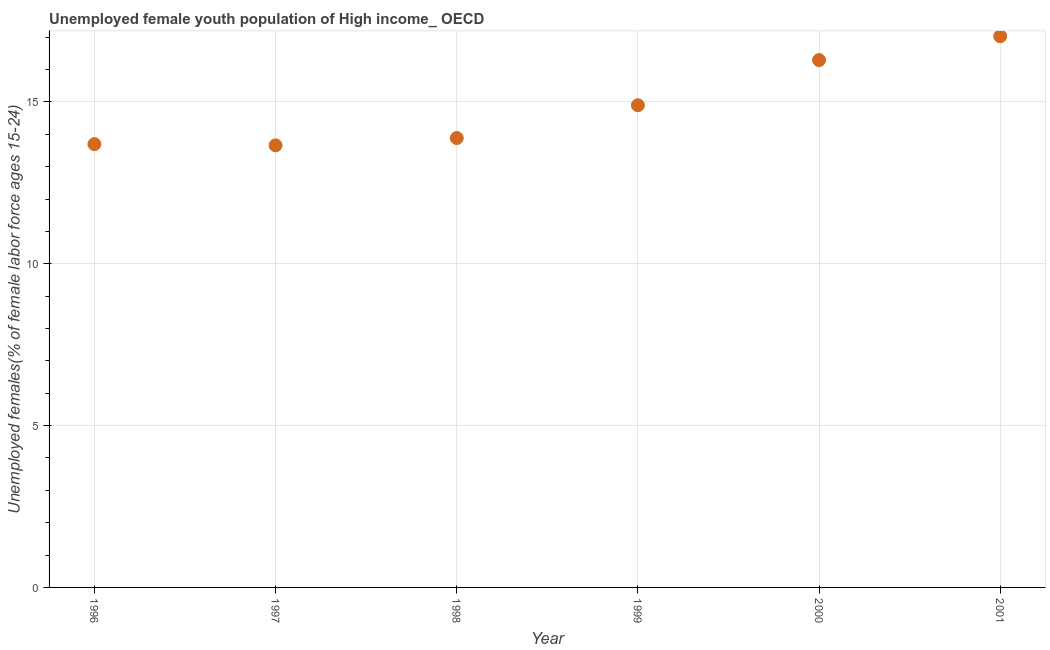What is the unemployed female youth in 1996?
Your answer should be very brief. 13.7. Across all years, what is the maximum unemployed female youth?
Your answer should be compact. 17.03. Across all years, what is the minimum unemployed female youth?
Offer a very short reply. 13.66. In which year was the unemployed female youth maximum?
Provide a succinct answer. 2001. In which year was the unemployed female youth minimum?
Make the answer very short. 1997. What is the sum of the unemployed female youth?
Your answer should be compact. 89.46. What is the difference between the unemployed female youth in 1998 and 2000?
Provide a succinct answer. -2.41. What is the average unemployed female youth per year?
Offer a very short reply. 14.91. What is the median unemployed female youth?
Ensure brevity in your answer.  14.39. In how many years, is the unemployed female youth greater than 14 %?
Offer a terse response. 3. What is the ratio of the unemployed female youth in 1998 to that in 2000?
Your answer should be very brief. 0.85. What is the difference between the highest and the second highest unemployed female youth?
Your answer should be very brief. 0.74. Is the sum of the unemployed female youth in 1996 and 1999 greater than the maximum unemployed female youth across all years?
Provide a short and direct response. Yes. What is the difference between the highest and the lowest unemployed female youth?
Provide a short and direct response. 3.37. Does the unemployed female youth monotonically increase over the years?
Make the answer very short. No. How many dotlines are there?
Your answer should be compact. 1. What is the difference between two consecutive major ticks on the Y-axis?
Offer a terse response. 5. Does the graph contain grids?
Provide a succinct answer. Yes. What is the title of the graph?
Offer a very short reply. Unemployed female youth population of High income_ OECD. What is the label or title of the Y-axis?
Offer a very short reply. Unemployed females(% of female labor force ages 15-24). What is the Unemployed females(% of female labor force ages 15-24) in 1996?
Offer a very short reply. 13.7. What is the Unemployed females(% of female labor force ages 15-24) in 1997?
Your response must be concise. 13.66. What is the Unemployed females(% of female labor force ages 15-24) in 1998?
Give a very brief answer. 13.88. What is the Unemployed females(% of female labor force ages 15-24) in 1999?
Provide a succinct answer. 14.9. What is the Unemployed females(% of female labor force ages 15-24) in 2000?
Offer a terse response. 16.29. What is the Unemployed females(% of female labor force ages 15-24) in 2001?
Provide a succinct answer. 17.03. What is the difference between the Unemployed females(% of female labor force ages 15-24) in 1996 and 1997?
Your answer should be very brief. 0.04. What is the difference between the Unemployed females(% of female labor force ages 15-24) in 1996 and 1998?
Offer a very short reply. -0.19. What is the difference between the Unemployed females(% of female labor force ages 15-24) in 1996 and 1999?
Your answer should be very brief. -1.2. What is the difference between the Unemployed females(% of female labor force ages 15-24) in 1996 and 2000?
Offer a terse response. -2.6. What is the difference between the Unemployed females(% of female labor force ages 15-24) in 1996 and 2001?
Your answer should be compact. -3.33. What is the difference between the Unemployed females(% of female labor force ages 15-24) in 1997 and 1998?
Your answer should be very brief. -0.22. What is the difference between the Unemployed females(% of female labor force ages 15-24) in 1997 and 1999?
Provide a succinct answer. -1.24. What is the difference between the Unemployed females(% of female labor force ages 15-24) in 1997 and 2000?
Keep it short and to the point. -2.63. What is the difference between the Unemployed females(% of female labor force ages 15-24) in 1997 and 2001?
Offer a terse response. -3.37. What is the difference between the Unemployed females(% of female labor force ages 15-24) in 1998 and 1999?
Give a very brief answer. -1.01. What is the difference between the Unemployed females(% of female labor force ages 15-24) in 1998 and 2000?
Offer a very short reply. -2.41. What is the difference between the Unemployed females(% of female labor force ages 15-24) in 1998 and 2001?
Your answer should be compact. -3.14. What is the difference between the Unemployed females(% of female labor force ages 15-24) in 1999 and 2000?
Your answer should be very brief. -1.4. What is the difference between the Unemployed females(% of female labor force ages 15-24) in 1999 and 2001?
Your answer should be very brief. -2.13. What is the difference between the Unemployed females(% of female labor force ages 15-24) in 2000 and 2001?
Keep it short and to the point. -0.74. What is the ratio of the Unemployed females(% of female labor force ages 15-24) in 1996 to that in 1997?
Provide a succinct answer. 1. What is the ratio of the Unemployed females(% of female labor force ages 15-24) in 1996 to that in 1999?
Ensure brevity in your answer.  0.92. What is the ratio of the Unemployed females(% of female labor force ages 15-24) in 1996 to that in 2000?
Provide a short and direct response. 0.84. What is the ratio of the Unemployed females(% of female labor force ages 15-24) in 1996 to that in 2001?
Your answer should be compact. 0.8. What is the ratio of the Unemployed females(% of female labor force ages 15-24) in 1997 to that in 1999?
Your answer should be compact. 0.92. What is the ratio of the Unemployed females(% of female labor force ages 15-24) in 1997 to that in 2000?
Give a very brief answer. 0.84. What is the ratio of the Unemployed females(% of female labor force ages 15-24) in 1997 to that in 2001?
Your answer should be very brief. 0.8. What is the ratio of the Unemployed females(% of female labor force ages 15-24) in 1998 to that in 1999?
Give a very brief answer. 0.93. What is the ratio of the Unemployed females(% of female labor force ages 15-24) in 1998 to that in 2000?
Your answer should be compact. 0.85. What is the ratio of the Unemployed females(% of female labor force ages 15-24) in 1998 to that in 2001?
Provide a succinct answer. 0.81. What is the ratio of the Unemployed females(% of female labor force ages 15-24) in 1999 to that in 2000?
Your response must be concise. 0.91. 